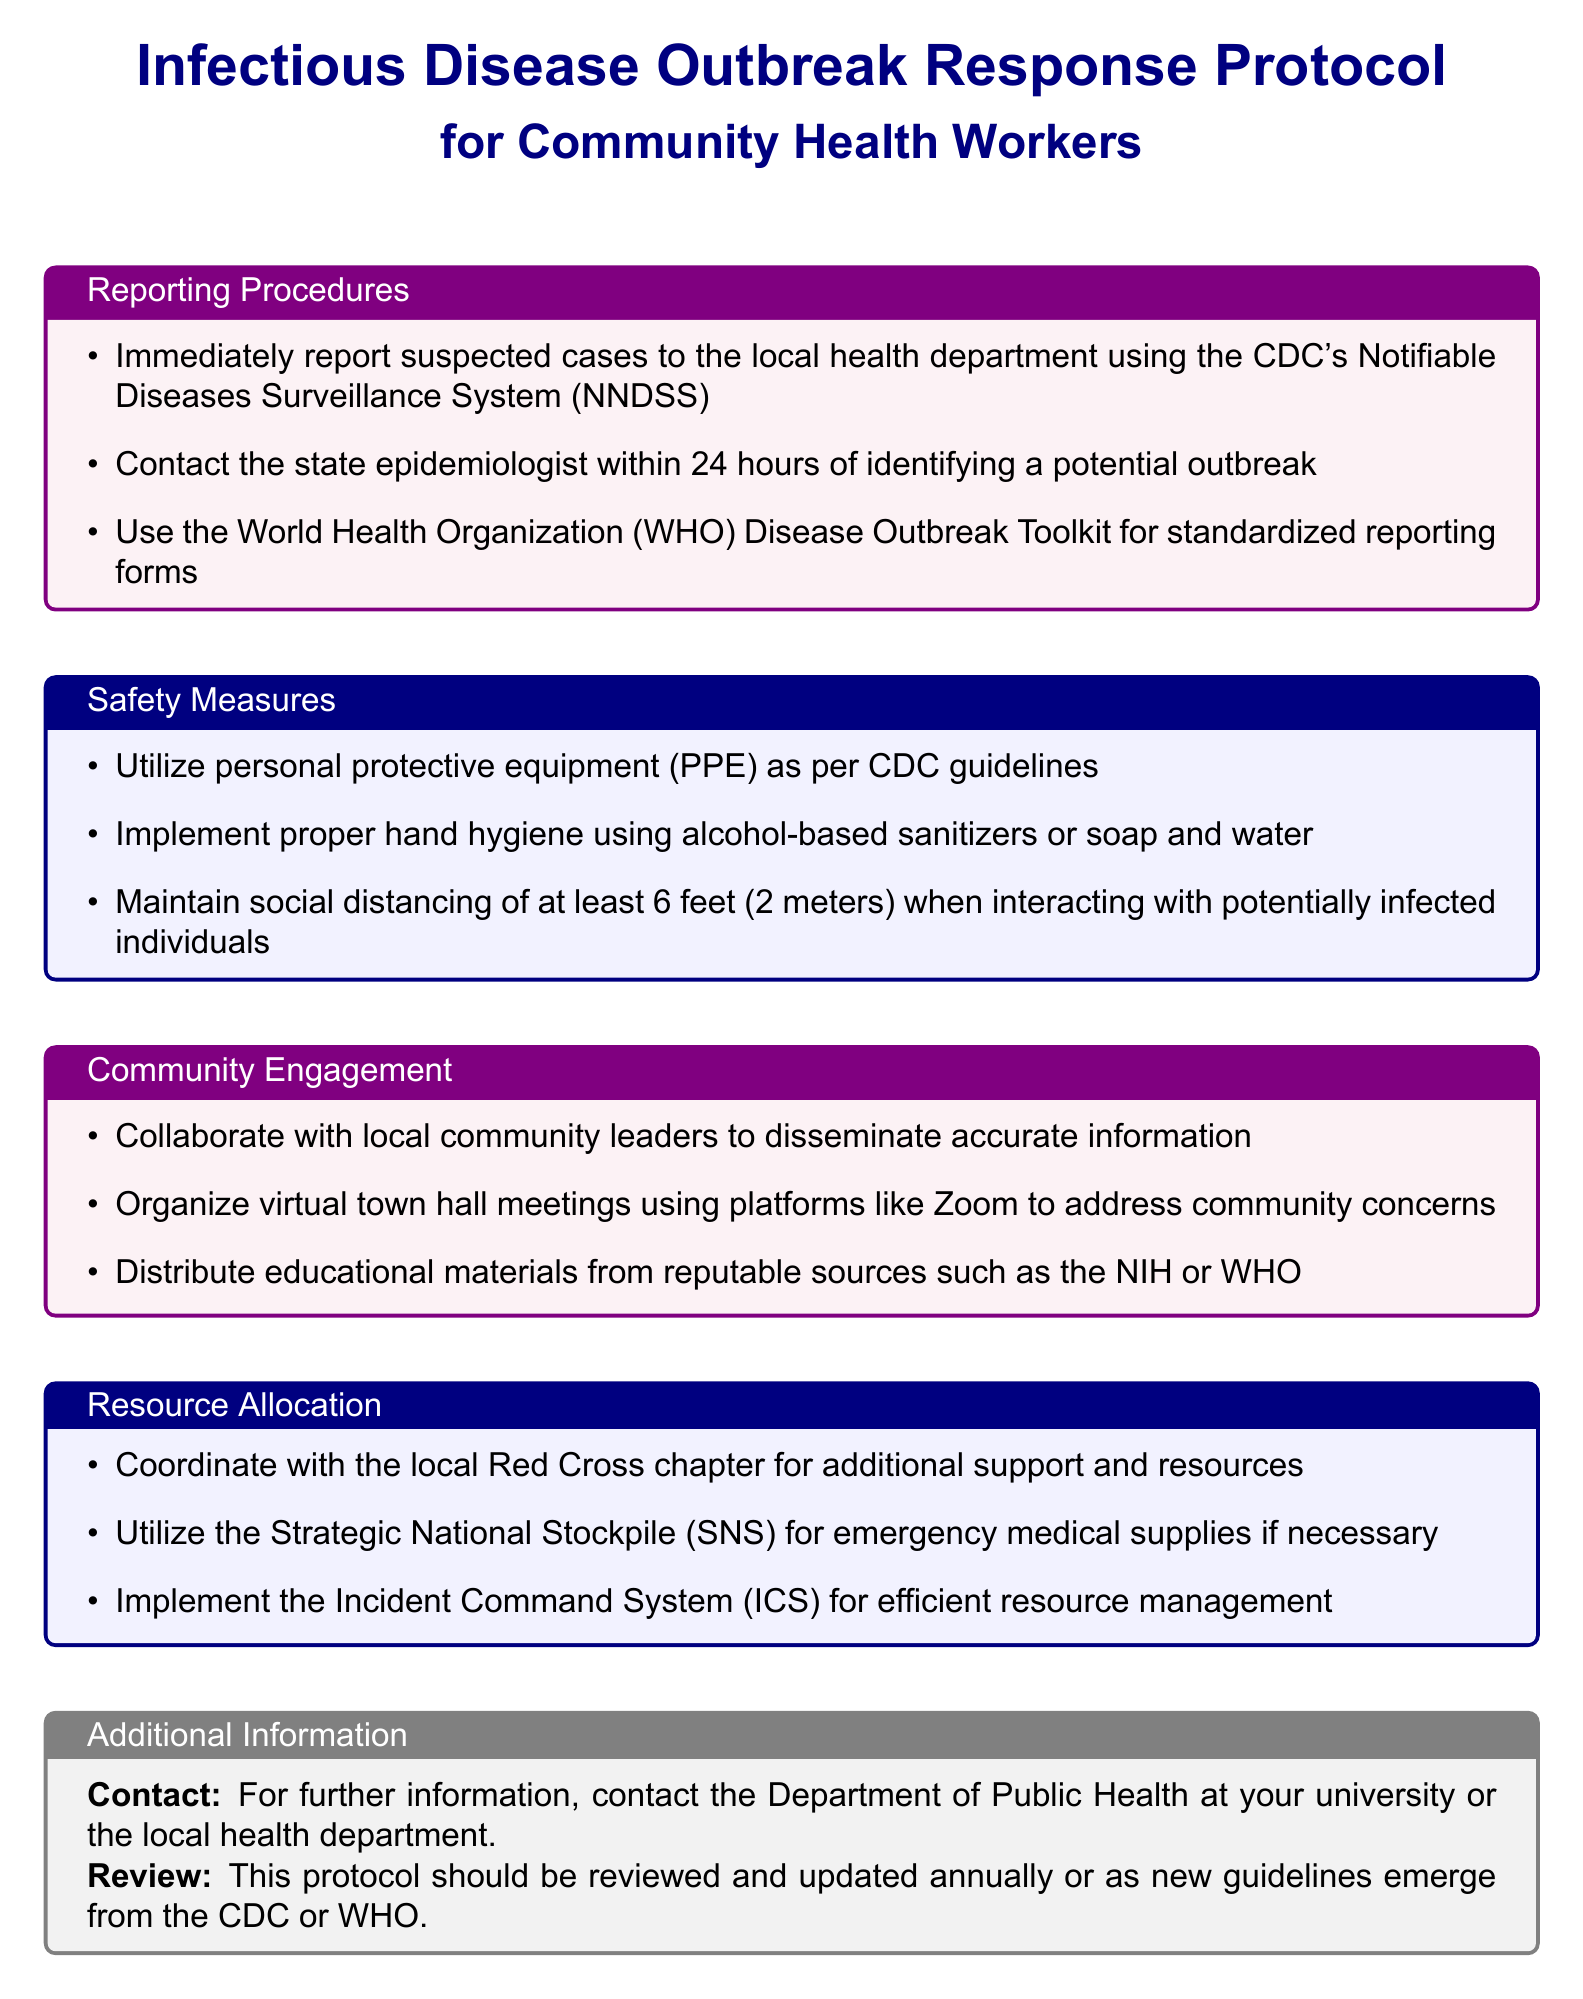what is the primary purpose of the document? The primary purpose is to outline the response protocol for infectious disease outbreaks for community health workers.
Answer: Infectious Disease Outbreak Response Protocol how soon must suspected cases be reported to the local health department? The document states that suspected cases must be reported immediately.
Answer: Immediately who should be contacted within 24 hours of identifying a potential outbreak? The document specifies that the state epidemiologist should be contacted.
Answer: State epidemiologist what personal protective equipment should be utilized? The document refers to using personal protective equipment as per CDC guidelines.
Answer: CDC guidelines what is the minimum social distancing requirement during interactions? The document specifies a social distancing requirement of at least 6 feet (2 meters).
Answer: 6 feet (2 meters) which organization is mentioned for collaboration to disseminate information? The document mentions collaborating with local community leaders.
Answer: Local community leaders what platform is suggested for virtual town hall meetings? The document suggests using Zoom for virtual town hall meetings.
Answer: Zoom which system should be implemented for efficient resource management? The document states that the Incident Command System (ICS) should be implemented.
Answer: Incident Command System (ICS) 